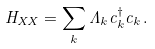Convert formula to latex. <formula><loc_0><loc_0><loc_500><loc_500>H _ { X X } = \sum _ { k } \Lambda _ { k } c _ { k } ^ { \dagger } c _ { k } \, .</formula> 